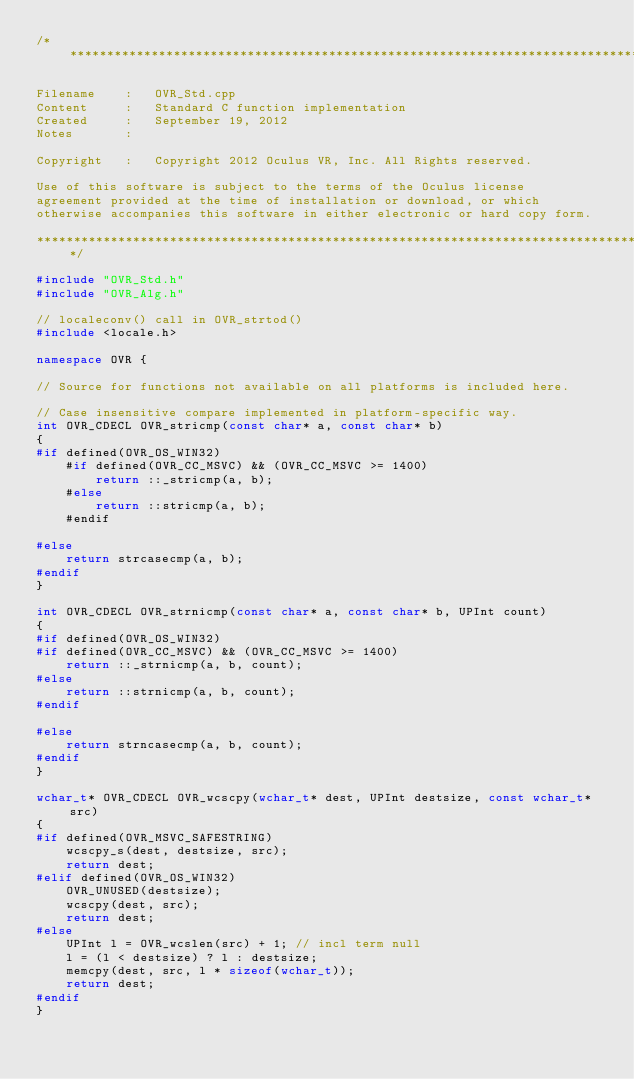Convert code to text. <code><loc_0><loc_0><loc_500><loc_500><_C++_>/************************************************************************************

Filename    :   OVR_Std.cpp
Content     :   Standard C function implementation
Created     :   September 19, 2012
Notes       : 

Copyright   :   Copyright 2012 Oculus VR, Inc. All Rights reserved.

Use of this software is subject to the terms of the Oculus license
agreement provided at the time of installation or download, or which
otherwise accompanies this software in either electronic or hard copy form.

************************************************************************************/

#include "OVR_Std.h"
#include "OVR_Alg.h"

// localeconv() call in OVR_strtod()
#include <locale.h>

namespace OVR {

// Source for functions not available on all platforms is included here.

// Case insensitive compare implemented in platform-specific way.
int OVR_CDECL OVR_stricmp(const char* a, const char* b)
{
#if defined(OVR_OS_WIN32)
    #if defined(OVR_CC_MSVC) && (OVR_CC_MSVC >= 1400)
        return ::_stricmp(a, b);
    #else
        return ::stricmp(a, b);
    #endif

#else
    return strcasecmp(a, b);
#endif
}

int OVR_CDECL OVR_strnicmp(const char* a, const char* b, UPInt count)
{
#if defined(OVR_OS_WIN32)
#if defined(OVR_CC_MSVC) && (OVR_CC_MSVC >= 1400)
    return ::_strnicmp(a, b, count);
#else
    return ::strnicmp(a, b, count);
#endif

#else
    return strncasecmp(a, b, count);
#endif
}

wchar_t* OVR_CDECL OVR_wcscpy(wchar_t* dest, UPInt destsize, const wchar_t* src)
{
#if defined(OVR_MSVC_SAFESTRING)
    wcscpy_s(dest, destsize, src);
    return dest;
#elif defined(OVR_OS_WIN32)
    OVR_UNUSED(destsize);
    wcscpy(dest, src);
    return dest;
#else
    UPInt l = OVR_wcslen(src) + 1; // incl term null
    l = (l < destsize) ? l : destsize;
    memcpy(dest, src, l * sizeof(wchar_t));
    return dest;
#endif
}
</code> 